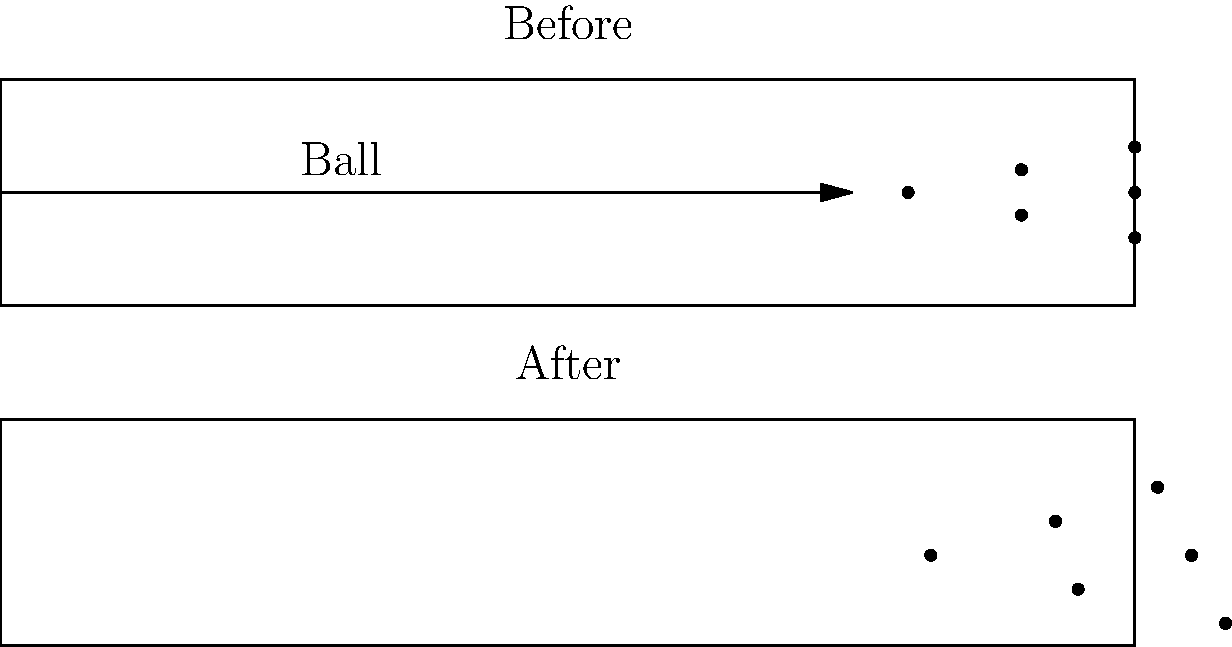Based on the before-and-after lane diagrams showing pin scatter patterns, what type of ball impact and reaction can be inferred, and how might this affect scoring potential? To analyze the pin scatter pattern and infer the ball impact and reaction:

1. Ball trajectory: The ball's path is straight and slightly right of center, aiming between the 1 and 3 pins.

2. Pin movement:
   a. The headpin (1 pin) moves back and slightly left.
   b. The 3 pin moves back and right.
   c. The 2 pin moves back and left.
   d. The 4, 5, and 6 pins show varied movement patterns.

3. Impact analysis: The ball likely hit the pocket (between 1 and 3 pins) with a slight angle, creating a strong pin action.

4. Pin reaction: The scatter pattern indicates good energy transfer and pin collision, suggesting a powerful and well-placed shot.

5. Scoring potential:
   a. The wide scatter increases the chance of all pins falling.
   b. The back pins (4, 5, 6) are pushed outward, reducing the likelihood of leaves.

6. Ball characteristics: The shot suggests a ball with strong backend reaction, likely a reactive resin or similar high-performance ball.

7. Player technique: The bowler demonstrates good accuracy and power, hitting the ideal pocket area for maximum pin action.

This type of shot, known as a "pocket hit," typically results in high scoring potential due to the effective energy transfer and wide pin scatter.
Answer: Pocket hit with strong pin action, high scoring potential 